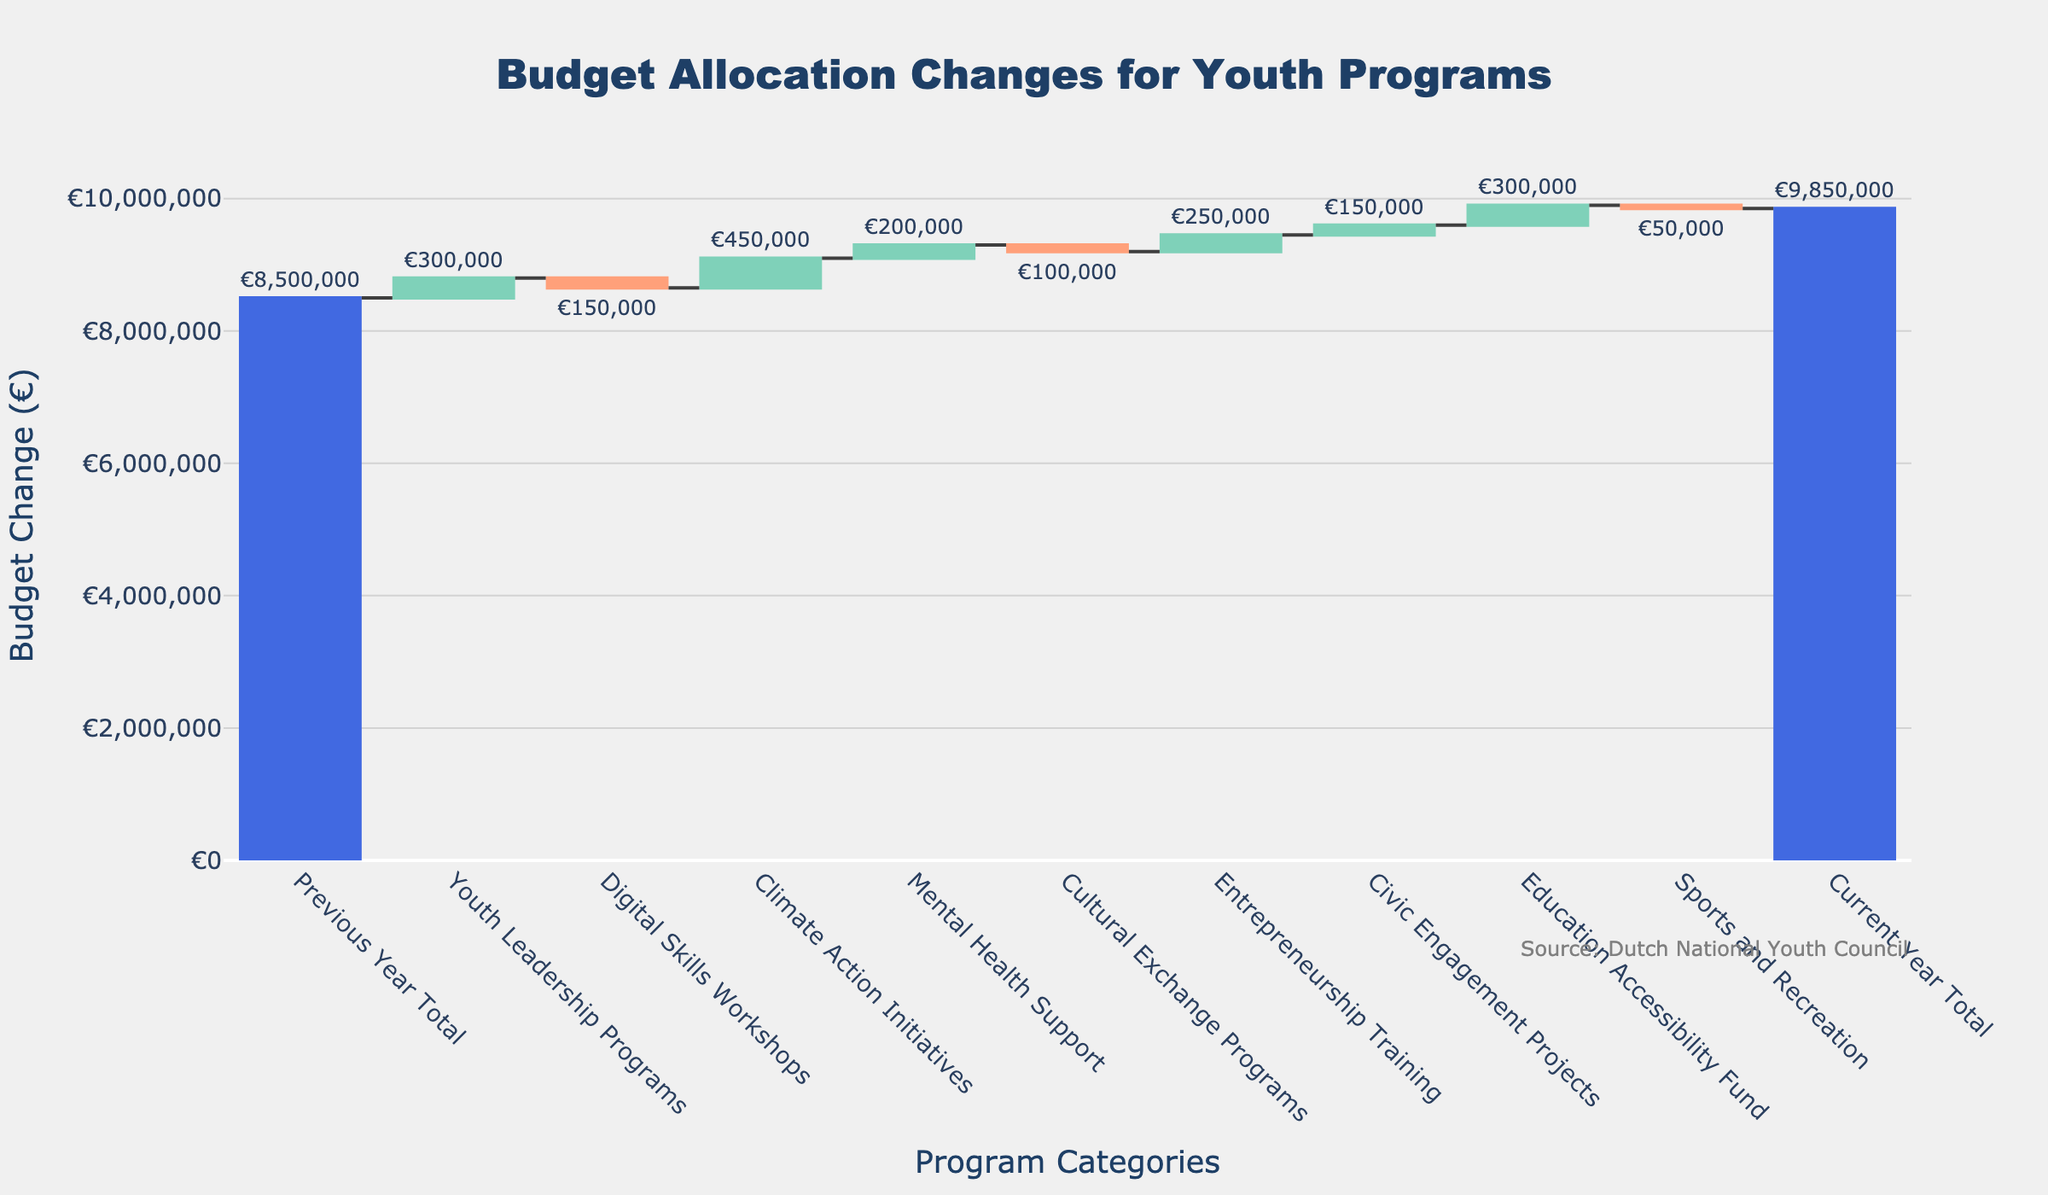What is the total budget allocation for youth programs for the current year? The title indicates that the chart shows budget changes for youth programs, and the x-axis lists categories with a final category named "Current Year Total." The y-value for this category shows the total budget for the current year.
Answer: €9,850,000 How much has the Youth Leadership Programs' budget changed compared to the previous year? Under the "Youth Leadership Programs" category, the y-value and the adjacent text indicate the budget change.
Answer: +€300,000 Which category experienced the largest increase in budget allocation? By comparing the heights of the bars and their labels that represent positive changes (green bars), the "Climate Action Initiatives" bar shows the largest increase.
Answer: Climate Action Initiatives How did the Sports and Recreation budget change from the previous year? Locate the "Sports and Recreation" category on the x-axis and observe the corresponding y-value and text. The text shows the budget change as -€50,000.
Answer: -€50,000 What is the total increase in budget allocation for all categories with a positive change? Identify categories with positive changes and sum their values: Youth Leadership Programs (+€300,000), Climate Action Initiatives (+€450,000), Mental Health Support (+€200,000), Entrepreneurship Training (+€250,000), Civic Engagement Projects (+€150,000), and Education Accessibility Fund (+€300,000).
Answer: €1,650,000 What is the net change in budget allocation for Digital Skills Workshops and Cultural Exchange Programs combined? Add the changes for Digital Skills Workshops (-€150,000) and Cultural Exchange Programs (-€100,000).
Answer: -€250,000 How does the initial budget of the previous year compare to the current year's budget? The initial budget of the previous year and the current year's budget are shown by the y-values for "Previous Year Total" and "Current Year Total" respectively. The previous year had €8,500,000 and the current year is €9,850,000.
Answer: €1,350,000 increase Which category had the smallest positive change in budget allocation? Among the categories with positive changes, compare the values and find the smallest one, which is "Civic Engagement Projects" with +€150,000.
Answer: Civic Engagement Projects How does the total decrease in budget allocation compare to the total increase? Sum the budget changes for negative values: Digital Skills Workshops (-€150,000) and Cultural Exchange Programs (-€100,000) and Sports and Recreation (-€50,000) totaling -€300,000, then compare this with the total increase of €1,650,000.
Answer: The total increase is significantly larger 